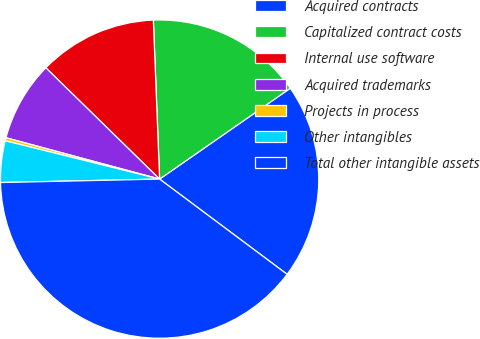<chart> <loc_0><loc_0><loc_500><loc_500><pie_chart><fcel>Acquired contracts<fcel>Capitalized contract costs<fcel>Internal use software<fcel>Acquired trademarks<fcel>Projects in process<fcel>Other intangibles<fcel>Total other intangible assets<nl><fcel>19.88%<fcel>15.96%<fcel>12.05%<fcel>8.14%<fcel>0.31%<fcel>4.22%<fcel>39.45%<nl></chart> 